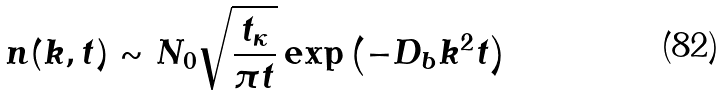Convert formula to latex. <formula><loc_0><loc_0><loc_500><loc_500>n ( k , t ) \sim N _ { 0 } \sqrt { \frac { t _ { \kappa } } { \pi t } } \exp \left ( - D _ { b } k ^ { 2 } t \right )</formula> 